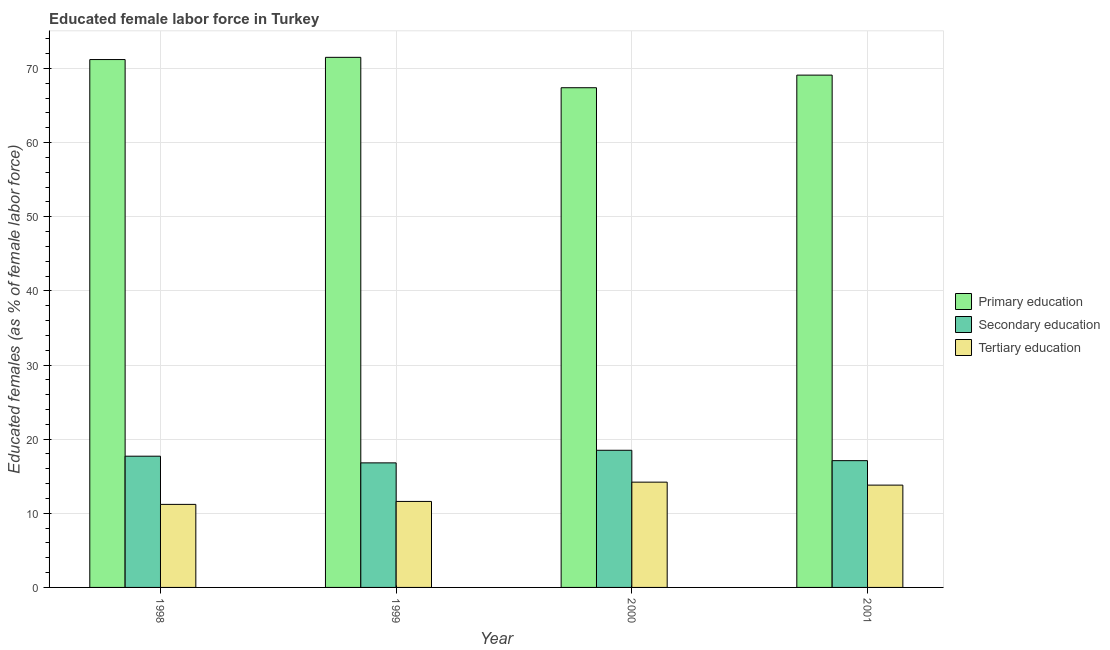Are the number of bars per tick equal to the number of legend labels?
Your response must be concise. Yes. Are the number of bars on each tick of the X-axis equal?
Provide a short and direct response. Yes. How many bars are there on the 2nd tick from the left?
Provide a short and direct response. 3. What is the label of the 3rd group of bars from the left?
Provide a short and direct response. 2000. What is the percentage of female labor force who received tertiary education in 2001?
Provide a short and direct response. 13.8. Across all years, what is the maximum percentage of female labor force who received primary education?
Provide a succinct answer. 71.5. Across all years, what is the minimum percentage of female labor force who received secondary education?
Make the answer very short. 16.8. In which year was the percentage of female labor force who received primary education maximum?
Offer a very short reply. 1999. What is the total percentage of female labor force who received secondary education in the graph?
Provide a short and direct response. 70.1. What is the difference between the percentage of female labor force who received secondary education in 1998 and that in 1999?
Ensure brevity in your answer.  0.9. What is the difference between the percentage of female labor force who received secondary education in 2000 and the percentage of female labor force who received primary education in 1999?
Your response must be concise. 1.7. What is the average percentage of female labor force who received primary education per year?
Provide a succinct answer. 69.8. What is the ratio of the percentage of female labor force who received secondary education in 1999 to that in 2001?
Offer a terse response. 0.98. Is the percentage of female labor force who received primary education in 1999 less than that in 2001?
Make the answer very short. No. What is the difference between the highest and the second highest percentage of female labor force who received secondary education?
Your answer should be very brief. 0.8. What is the difference between the highest and the lowest percentage of female labor force who received tertiary education?
Your response must be concise. 3. Is the sum of the percentage of female labor force who received tertiary education in 2000 and 2001 greater than the maximum percentage of female labor force who received secondary education across all years?
Make the answer very short. Yes. What does the 2nd bar from the left in 1999 represents?
Provide a short and direct response. Secondary education. What does the 1st bar from the right in 1998 represents?
Ensure brevity in your answer.  Tertiary education. Is it the case that in every year, the sum of the percentage of female labor force who received primary education and percentage of female labor force who received secondary education is greater than the percentage of female labor force who received tertiary education?
Give a very brief answer. Yes. How many years are there in the graph?
Ensure brevity in your answer.  4. Are the values on the major ticks of Y-axis written in scientific E-notation?
Provide a succinct answer. No. Does the graph contain any zero values?
Provide a short and direct response. No. Does the graph contain grids?
Your response must be concise. Yes. How are the legend labels stacked?
Make the answer very short. Vertical. What is the title of the graph?
Offer a terse response. Educated female labor force in Turkey. Does "Agriculture" appear as one of the legend labels in the graph?
Your response must be concise. No. What is the label or title of the X-axis?
Your response must be concise. Year. What is the label or title of the Y-axis?
Provide a succinct answer. Educated females (as % of female labor force). What is the Educated females (as % of female labor force) of Primary education in 1998?
Your answer should be very brief. 71.2. What is the Educated females (as % of female labor force) of Secondary education in 1998?
Your answer should be very brief. 17.7. What is the Educated females (as % of female labor force) of Tertiary education in 1998?
Your answer should be very brief. 11.2. What is the Educated females (as % of female labor force) in Primary education in 1999?
Your response must be concise. 71.5. What is the Educated females (as % of female labor force) in Secondary education in 1999?
Provide a succinct answer. 16.8. What is the Educated females (as % of female labor force) of Tertiary education in 1999?
Keep it short and to the point. 11.6. What is the Educated females (as % of female labor force) of Primary education in 2000?
Your answer should be very brief. 67.4. What is the Educated females (as % of female labor force) of Tertiary education in 2000?
Make the answer very short. 14.2. What is the Educated females (as % of female labor force) in Primary education in 2001?
Ensure brevity in your answer.  69.1. What is the Educated females (as % of female labor force) of Secondary education in 2001?
Offer a terse response. 17.1. What is the Educated females (as % of female labor force) in Tertiary education in 2001?
Offer a terse response. 13.8. Across all years, what is the maximum Educated females (as % of female labor force) in Primary education?
Offer a terse response. 71.5. Across all years, what is the maximum Educated females (as % of female labor force) of Tertiary education?
Keep it short and to the point. 14.2. Across all years, what is the minimum Educated females (as % of female labor force) of Primary education?
Keep it short and to the point. 67.4. Across all years, what is the minimum Educated females (as % of female labor force) of Secondary education?
Provide a succinct answer. 16.8. Across all years, what is the minimum Educated females (as % of female labor force) of Tertiary education?
Give a very brief answer. 11.2. What is the total Educated females (as % of female labor force) in Primary education in the graph?
Ensure brevity in your answer.  279.2. What is the total Educated females (as % of female labor force) of Secondary education in the graph?
Offer a very short reply. 70.1. What is the total Educated females (as % of female labor force) in Tertiary education in the graph?
Ensure brevity in your answer.  50.8. What is the difference between the Educated females (as % of female labor force) of Secondary education in 1998 and that in 2000?
Make the answer very short. -0.8. What is the difference between the Educated females (as % of female labor force) in Tertiary education in 1998 and that in 2000?
Give a very brief answer. -3. What is the difference between the Educated females (as % of female labor force) of Tertiary education in 1998 and that in 2001?
Keep it short and to the point. -2.6. What is the difference between the Educated females (as % of female labor force) in Primary education in 2000 and that in 2001?
Keep it short and to the point. -1.7. What is the difference between the Educated females (as % of female labor force) of Secondary education in 2000 and that in 2001?
Keep it short and to the point. 1.4. What is the difference between the Educated females (as % of female labor force) in Tertiary education in 2000 and that in 2001?
Offer a very short reply. 0.4. What is the difference between the Educated females (as % of female labor force) in Primary education in 1998 and the Educated females (as % of female labor force) in Secondary education in 1999?
Your answer should be compact. 54.4. What is the difference between the Educated females (as % of female labor force) of Primary education in 1998 and the Educated females (as % of female labor force) of Tertiary education in 1999?
Provide a short and direct response. 59.6. What is the difference between the Educated females (as % of female labor force) in Primary education in 1998 and the Educated females (as % of female labor force) in Secondary education in 2000?
Your answer should be compact. 52.7. What is the difference between the Educated females (as % of female labor force) of Primary education in 1998 and the Educated females (as % of female labor force) of Secondary education in 2001?
Give a very brief answer. 54.1. What is the difference between the Educated females (as % of female labor force) of Primary education in 1998 and the Educated females (as % of female labor force) of Tertiary education in 2001?
Provide a short and direct response. 57.4. What is the difference between the Educated females (as % of female labor force) of Primary education in 1999 and the Educated females (as % of female labor force) of Secondary education in 2000?
Your response must be concise. 53. What is the difference between the Educated females (as % of female labor force) of Primary education in 1999 and the Educated females (as % of female labor force) of Tertiary education in 2000?
Offer a terse response. 57.3. What is the difference between the Educated females (as % of female labor force) of Primary education in 1999 and the Educated females (as % of female labor force) of Secondary education in 2001?
Offer a very short reply. 54.4. What is the difference between the Educated females (as % of female labor force) of Primary education in 1999 and the Educated females (as % of female labor force) of Tertiary education in 2001?
Your answer should be very brief. 57.7. What is the difference between the Educated females (as % of female labor force) in Primary education in 2000 and the Educated females (as % of female labor force) in Secondary education in 2001?
Provide a succinct answer. 50.3. What is the difference between the Educated females (as % of female labor force) in Primary education in 2000 and the Educated females (as % of female labor force) in Tertiary education in 2001?
Your answer should be compact. 53.6. What is the difference between the Educated females (as % of female labor force) in Secondary education in 2000 and the Educated females (as % of female labor force) in Tertiary education in 2001?
Keep it short and to the point. 4.7. What is the average Educated females (as % of female labor force) in Primary education per year?
Provide a short and direct response. 69.8. What is the average Educated females (as % of female labor force) of Secondary education per year?
Provide a succinct answer. 17.52. What is the average Educated females (as % of female labor force) in Tertiary education per year?
Provide a short and direct response. 12.7. In the year 1998, what is the difference between the Educated females (as % of female labor force) in Primary education and Educated females (as % of female labor force) in Secondary education?
Keep it short and to the point. 53.5. In the year 1998, what is the difference between the Educated females (as % of female labor force) in Primary education and Educated females (as % of female labor force) in Tertiary education?
Offer a terse response. 60. In the year 1999, what is the difference between the Educated females (as % of female labor force) of Primary education and Educated females (as % of female labor force) of Secondary education?
Your response must be concise. 54.7. In the year 1999, what is the difference between the Educated females (as % of female labor force) of Primary education and Educated females (as % of female labor force) of Tertiary education?
Provide a succinct answer. 59.9. In the year 1999, what is the difference between the Educated females (as % of female labor force) of Secondary education and Educated females (as % of female labor force) of Tertiary education?
Your response must be concise. 5.2. In the year 2000, what is the difference between the Educated females (as % of female labor force) of Primary education and Educated females (as % of female labor force) of Secondary education?
Ensure brevity in your answer.  48.9. In the year 2000, what is the difference between the Educated females (as % of female labor force) in Primary education and Educated females (as % of female labor force) in Tertiary education?
Ensure brevity in your answer.  53.2. In the year 2001, what is the difference between the Educated females (as % of female labor force) of Primary education and Educated females (as % of female labor force) of Tertiary education?
Give a very brief answer. 55.3. In the year 2001, what is the difference between the Educated females (as % of female labor force) of Secondary education and Educated females (as % of female labor force) of Tertiary education?
Make the answer very short. 3.3. What is the ratio of the Educated females (as % of female labor force) of Secondary education in 1998 to that in 1999?
Provide a succinct answer. 1.05. What is the ratio of the Educated females (as % of female labor force) of Tertiary education in 1998 to that in 1999?
Give a very brief answer. 0.97. What is the ratio of the Educated females (as % of female labor force) in Primary education in 1998 to that in 2000?
Provide a short and direct response. 1.06. What is the ratio of the Educated females (as % of female labor force) in Secondary education in 1998 to that in 2000?
Give a very brief answer. 0.96. What is the ratio of the Educated females (as % of female labor force) in Tertiary education in 1998 to that in 2000?
Provide a succinct answer. 0.79. What is the ratio of the Educated females (as % of female labor force) of Primary education in 1998 to that in 2001?
Give a very brief answer. 1.03. What is the ratio of the Educated females (as % of female labor force) of Secondary education in 1998 to that in 2001?
Give a very brief answer. 1.04. What is the ratio of the Educated females (as % of female labor force) of Tertiary education in 1998 to that in 2001?
Provide a short and direct response. 0.81. What is the ratio of the Educated females (as % of female labor force) of Primary education in 1999 to that in 2000?
Make the answer very short. 1.06. What is the ratio of the Educated females (as % of female labor force) in Secondary education in 1999 to that in 2000?
Make the answer very short. 0.91. What is the ratio of the Educated females (as % of female labor force) in Tertiary education in 1999 to that in 2000?
Offer a very short reply. 0.82. What is the ratio of the Educated females (as % of female labor force) of Primary education in 1999 to that in 2001?
Your response must be concise. 1.03. What is the ratio of the Educated females (as % of female labor force) in Secondary education in 1999 to that in 2001?
Keep it short and to the point. 0.98. What is the ratio of the Educated females (as % of female labor force) of Tertiary education in 1999 to that in 2001?
Provide a succinct answer. 0.84. What is the ratio of the Educated females (as % of female labor force) in Primary education in 2000 to that in 2001?
Offer a very short reply. 0.98. What is the ratio of the Educated females (as % of female labor force) in Secondary education in 2000 to that in 2001?
Provide a succinct answer. 1.08. What is the ratio of the Educated females (as % of female labor force) in Tertiary education in 2000 to that in 2001?
Provide a succinct answer. 1.03. What is the difference between the highest and the second highest Educated females (as % of female labor force) in Secondary education?
Give a very brief answer. 0.8. What is the difference between the highest and the second highest Educated females (as % of female labor force) in Tertiary education?
Offer a terse response. 0.4. What is the difference between the highest and the lowest Educated females (as % of female labor force) of Secondary education?
Make the answer very short. 1.7. What is the difference between the highest and the lowest Educated females (as % of female labor force) in Tertiary education?
Offer a very short reply. 3. 